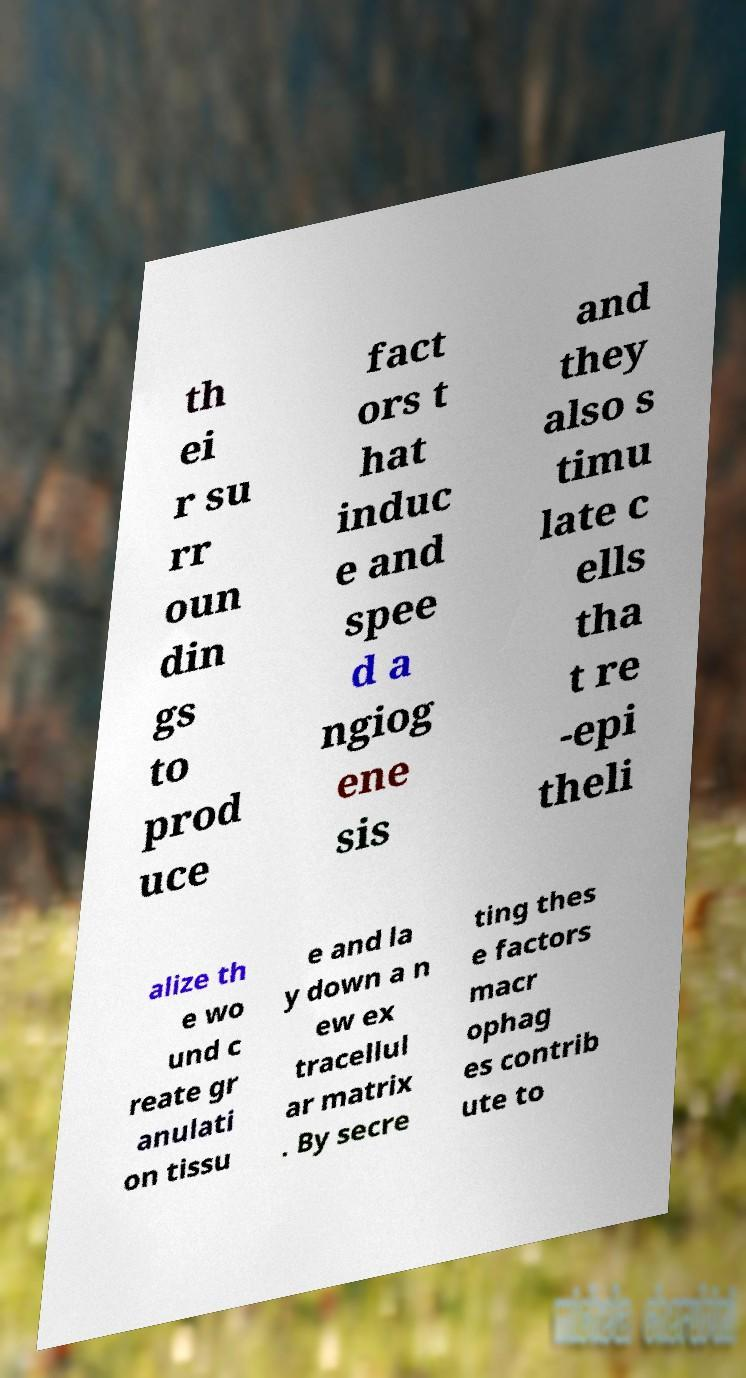I need the written content from this picture converted into text. Can you do that? th ei r su rr oun din gs to prod uce fact ors t hat induc e and spee d a ngiog ene sis and they also s timu late c ells tha t re -epi theli alize th e wo und c reate gr anulati on tissu e and la y down a n ew ex tracellul ar matrix . By secre ting thes e factors macr ophag es contrib ute to 